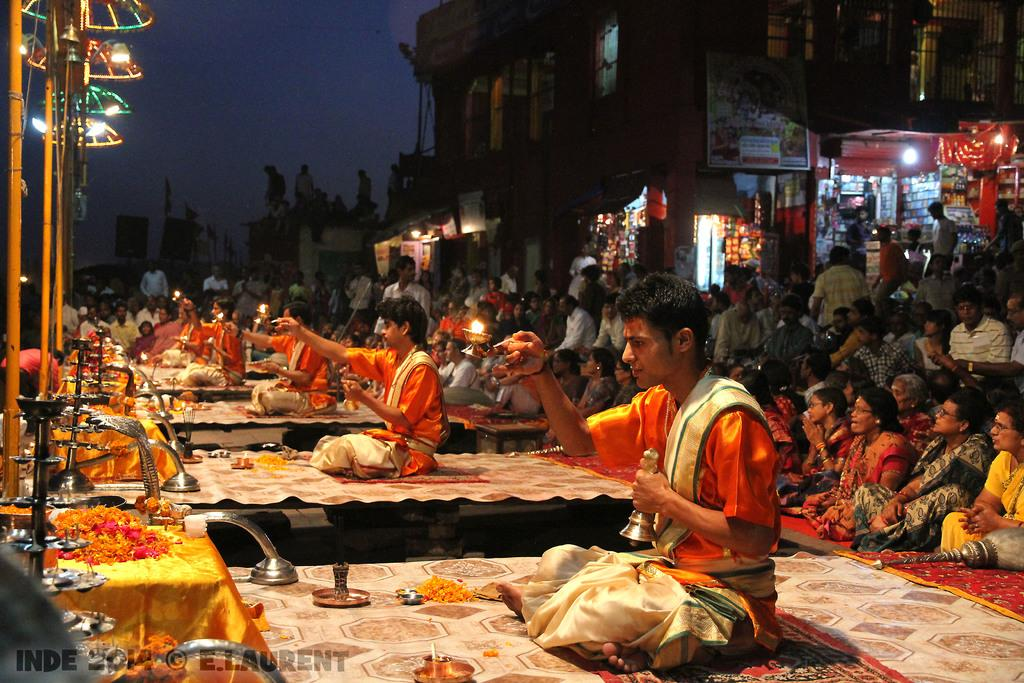What are the people in the image doing? The people in the image are sitting on the floor. What type of natural elements can be seen in the image? There are flowers in the image. What type of man-made structures are visible in the image? There are buildings and shops in the image. Can you describe any other elements in the image? There are other unspecified things in the image. What type of tin can be seen in the image? There is no tin present in the image. What is the way people are moving in the image? The people in the image are sitting on the floor, so there is no movement or way to describe their motion. 